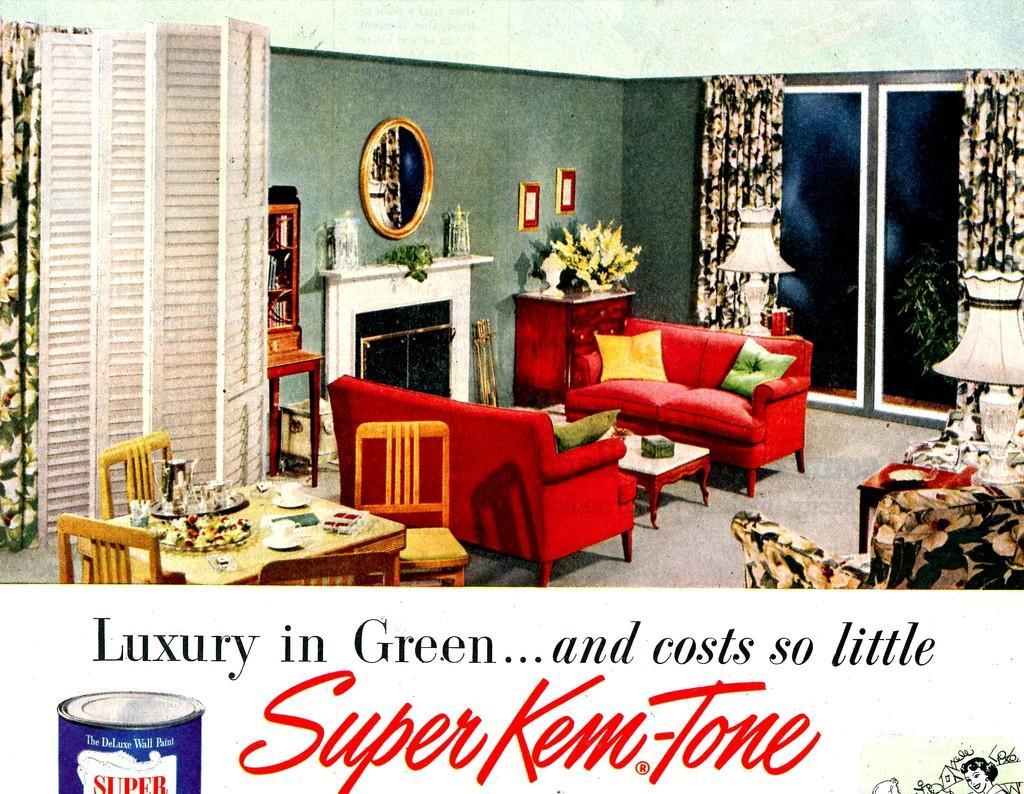Describe this image in one or two sentences. In this image there is a poster having painting and some text. There is a sofa having cushions. Before the sofa there is a table having an object on it. Left side there is a table which is surrounded by few chairs. On the table there are few plates, cups and few objects on it. Right side there is a chair. Behind there is a table having a lamp on it. A mirror and few frames are attached to the wall. Background there is a wall having window which is covered with curtains. Bottom of the image there is some text and an image of a can. Before the window there is a lamp on the table. 